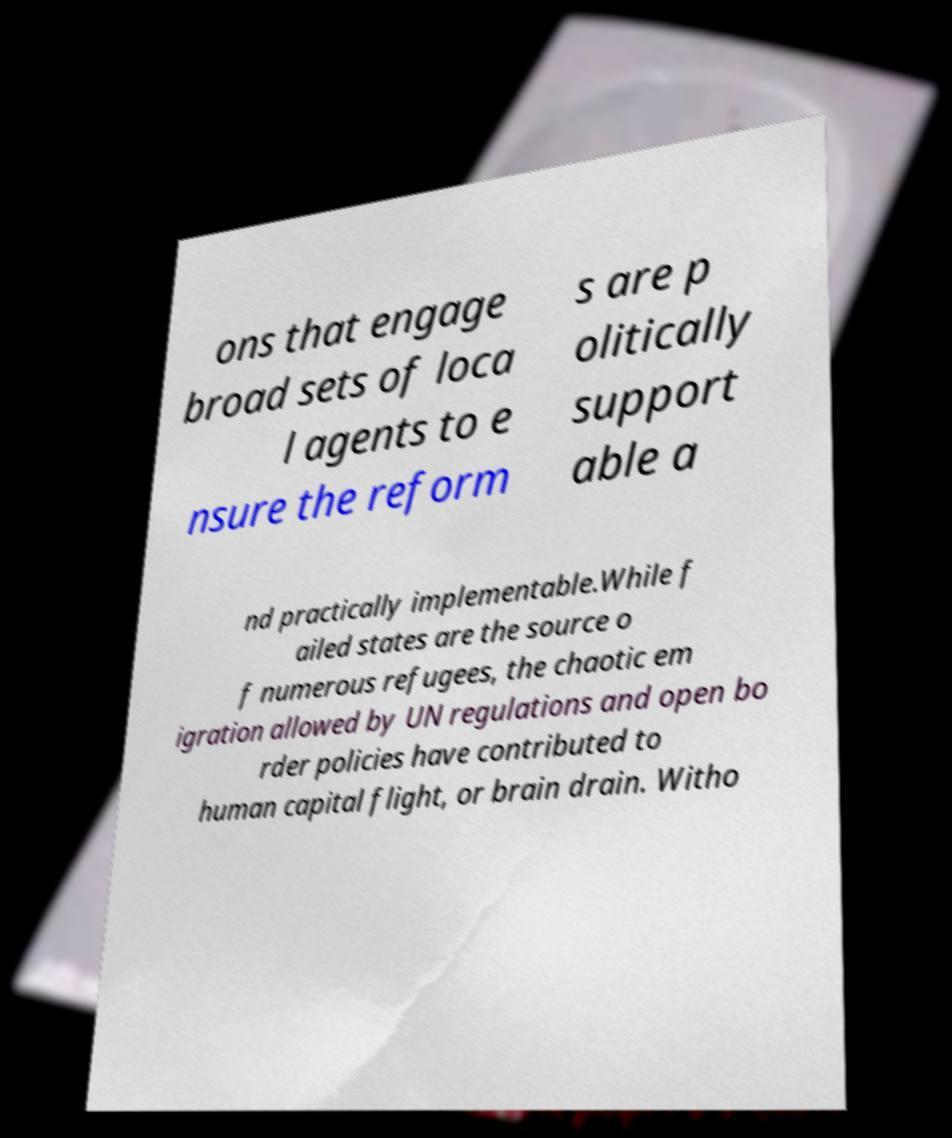What messages or text are displayed in this image? I need them in a readable, typed format. ons that engage broad sets of loca l agents to e nsure the reform s are p olitically support able a nd practically implementable.While f ailed states are the source o f numerous refugees, the chaotic em igration allowed by UN regulations and open bo rder policies have contributed to human capital flight, or brain drain. Witho 